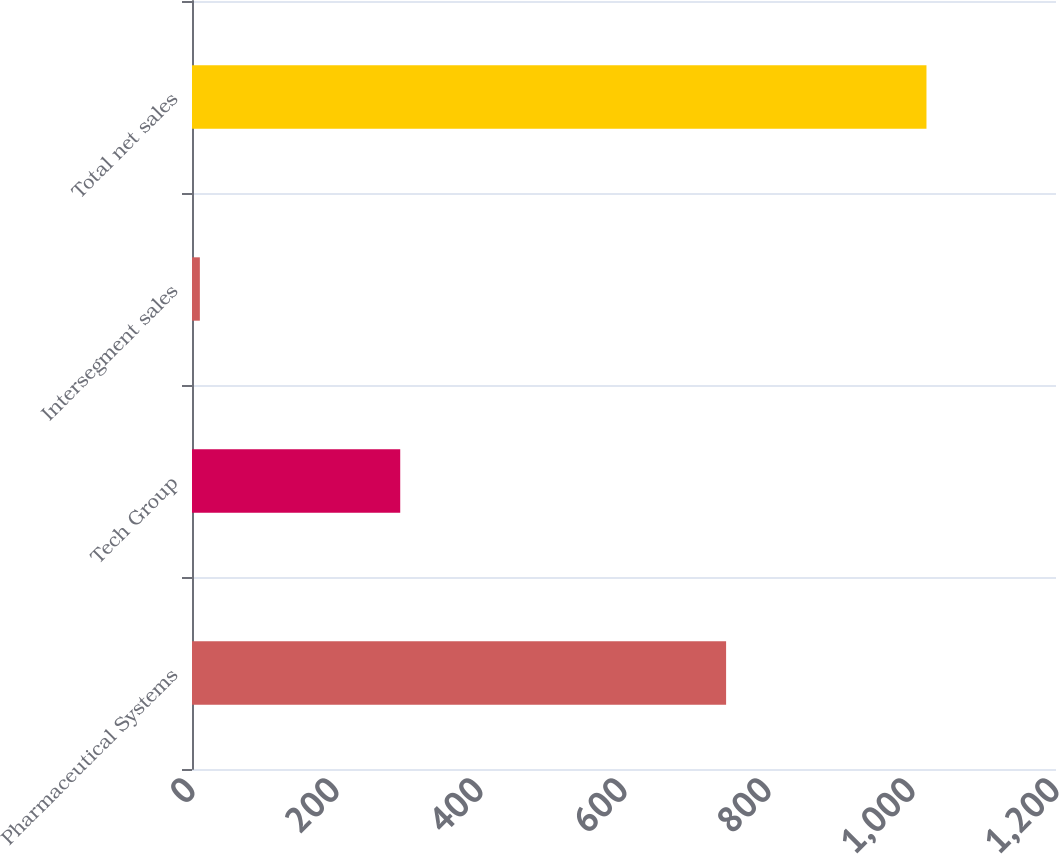<chart> <loc_0><loc_0><loc_500><loc_500><bar_chart><fcel>Pharmaceutical Systems<fcel>Tech Group<fcel>Intersegment sales<fcel>Total net sales<nl><fcel>741.8<fcel>289.2<fcel>10.9<fcel>1020.1<nl></chart> 